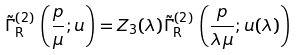Convert formula to latex. <formula><loc_0><loc_0><loc_500><loc_500>\tilde { \Gamma } _ { \text {R} } ^ { ( 2 ) } \, \left ( \frac { p } { \mu } ; u \right ) = Z _ { 3 } ( \lambda ) \tilde { \Gamma } _ { \text {R} } ^ { ( 2 ) } \, \left ( \frac { p } { \lambda \mu } ; u ( \lambda ) \right )</formula> 